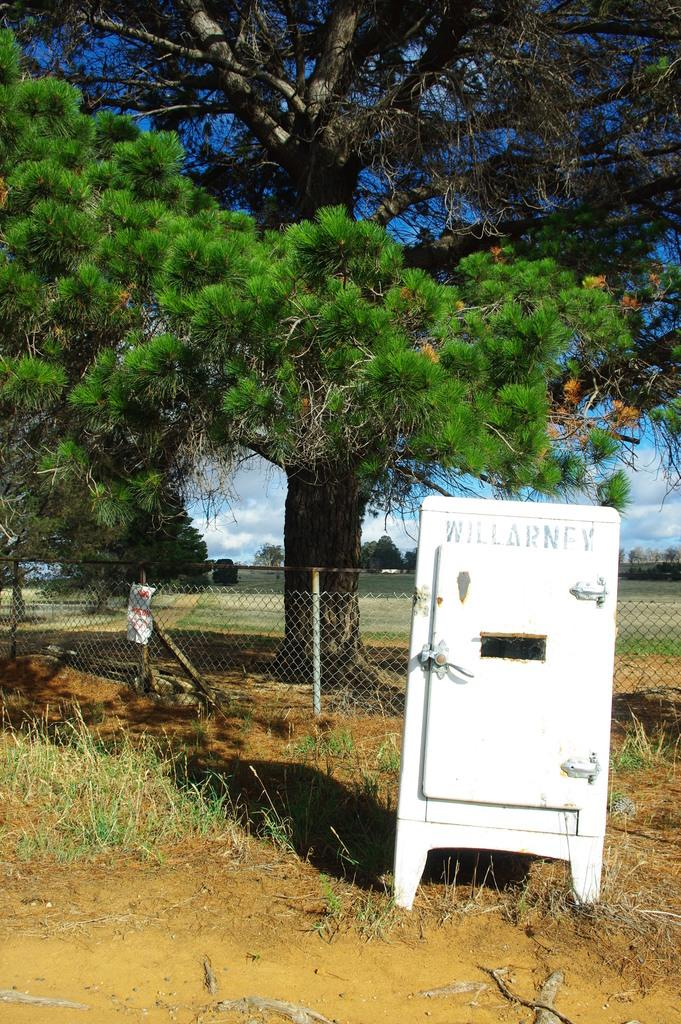What type of vegetation is present in the image? There are many trees in the image. How would you describe the sky in the image? The sky is cloudy in the image. What is the ground made of in the image? There is a grassy land in the image. What type of barrier is visible in the image? There is a fencing in the image. What is placed on the fencing? There is a paper on the fencing. Can you describe the object in the image? There is an object in the image, but its specific details are not mentioned in the facts. What type of trousers are hanging on the trees in the image? There are no trousers present in the image; it features trees, a cloudy sky, grassy land, fencing, a paper on the fencing, and an unspecified object. What is the copper content of the object in the image? The facts do not mention any information about the object's composition, including copper content. 